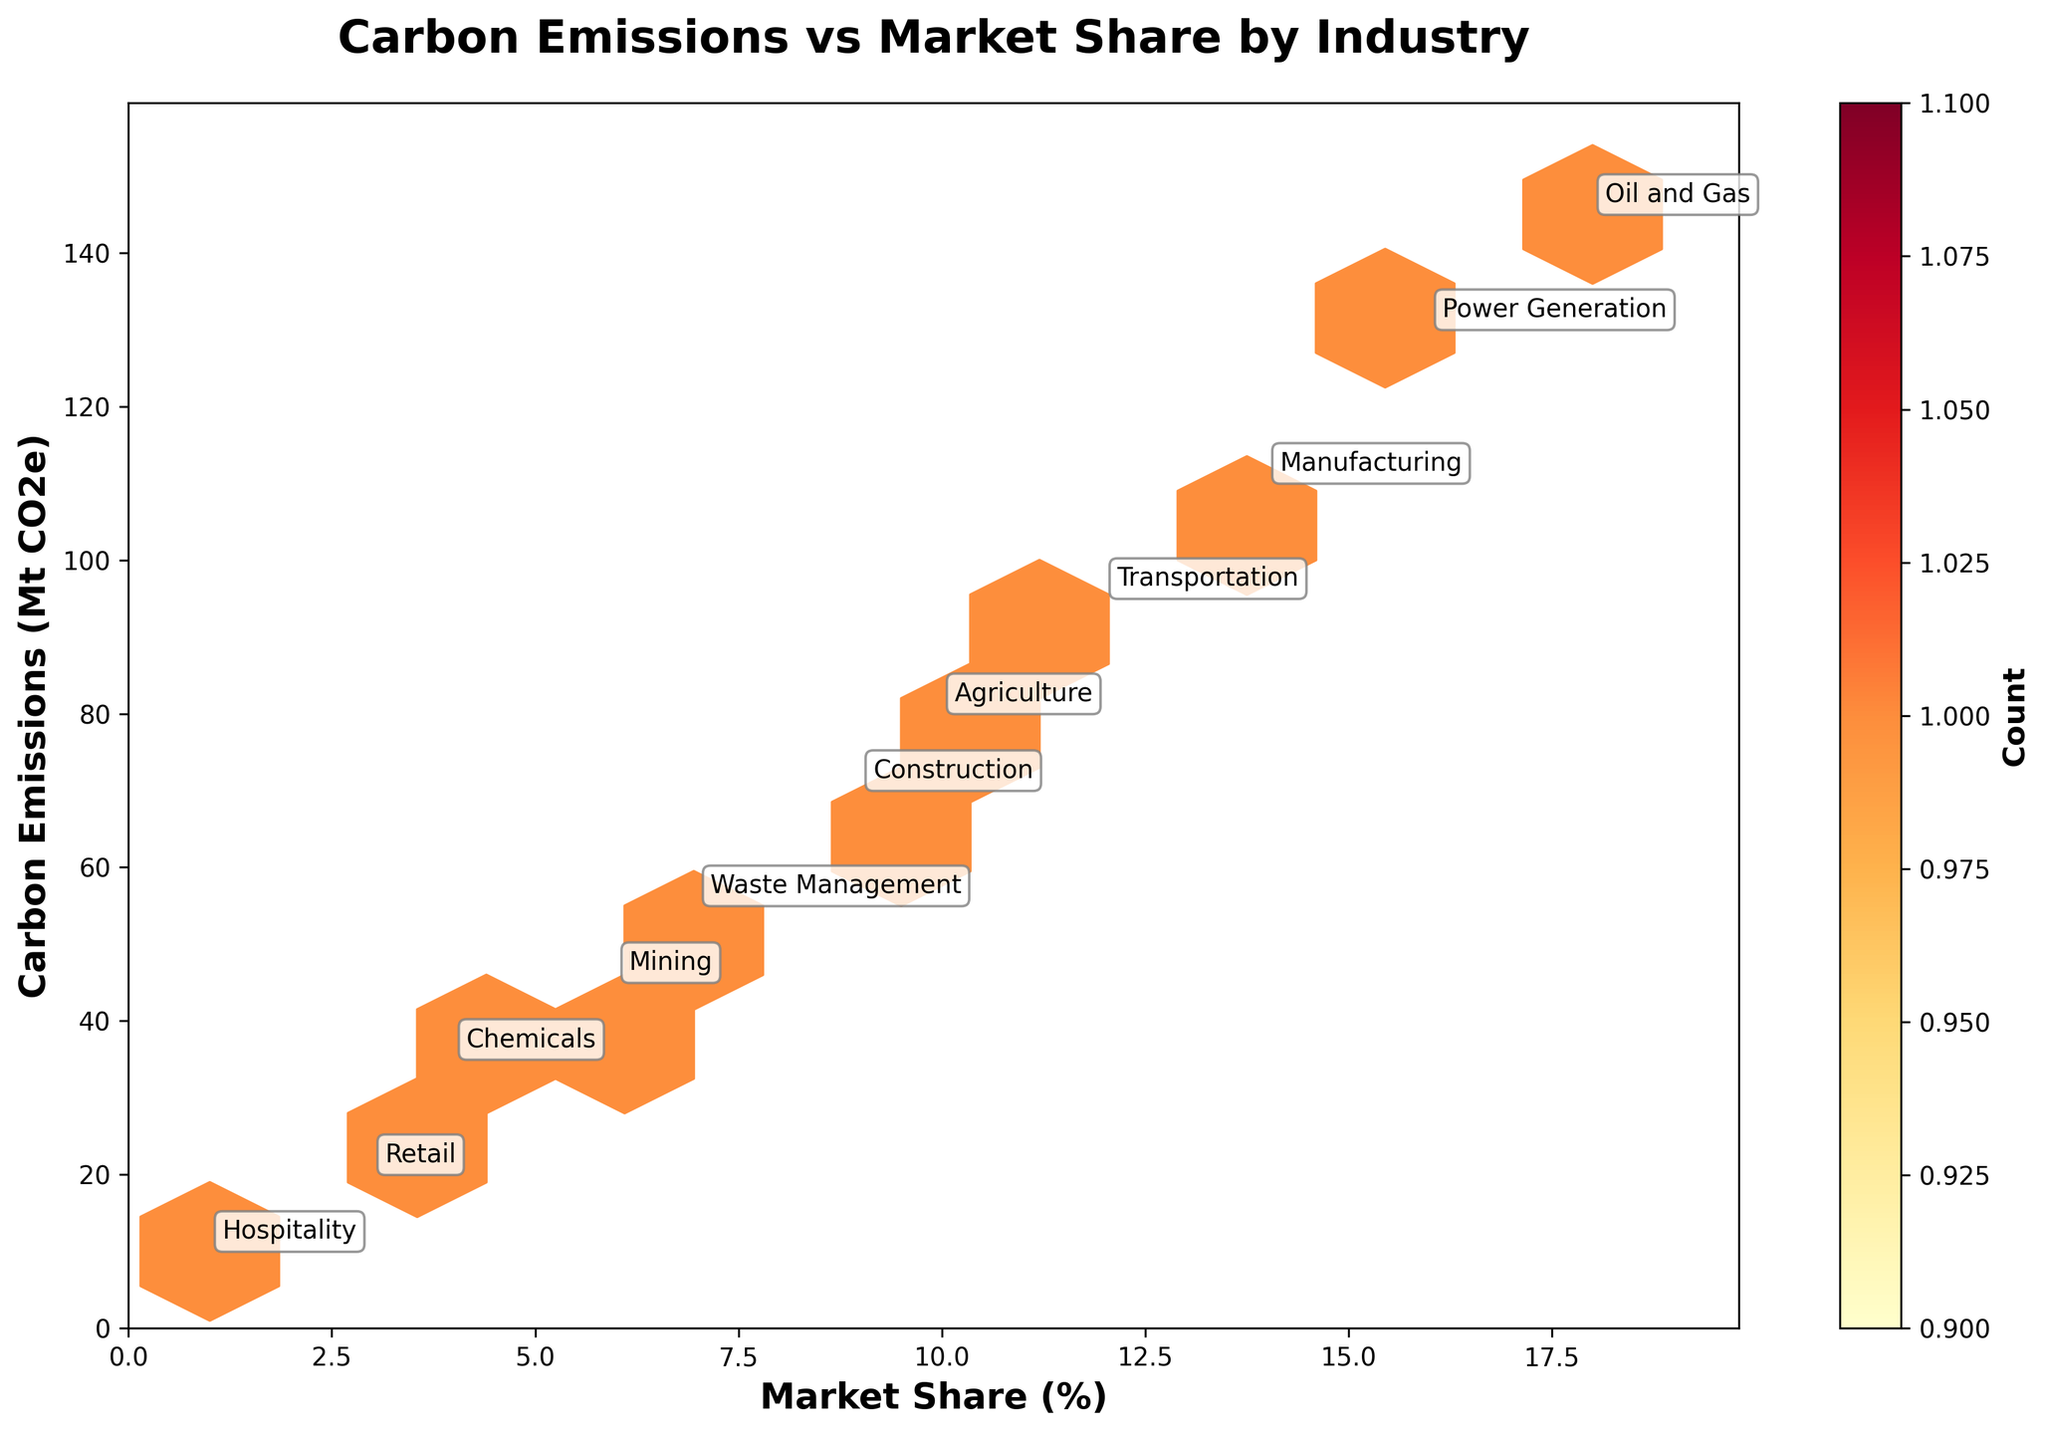What is the title of the plot? The title of the plot is displayed at the top of the figure and generally describes what the figure is about. In this case, it summarizes the content of the graph.
Answer: Carbon Emissions vs Market Share by Industry What color is used to represent the density of data points? The color used to represent the density of data points in a hexbin plot is typically indicated by the colorbar on the side of the plot. Here, different shades of yellow, orange, and red are used, with darker colors representing higher density areas.
Answer: Yellow to Red What is the market share percentage of the industry with the highest carbon emissions? To find this, locate the industry with the highest carbon emissions on the y-axis and then trace it to the corresponding market share on the x-axis. The Oil and Gas industry at 145 Mt CO2e has the highest carbon emissions.
Answer: 18% Which industry has the smallest carbon emissions and what is its market share percentage? To find this, locate the industry with the smallest carbon emissions on the y-axis and then look at the corresponding market share on the x-axis. The Hospitality industry with 10 Mt CO2e has the smallest emissions.
Answer: 1% How are the emissions and market share related among the industries shown in the plot? By examining the distribution of points, one can see whether there's a trend or pattern. Generally, the industries with higher emissions tend to have larger market shares, though there are variations.
Answer: Higher emissions often correlate with larger market shares What is the combined carbon emissions of Manufacturing and Transportation industries? The carbon emissions for Manufacturing and Transportation are 110 Mt CO2e and 95 Mt CO2e respectively. Summing them up: 110 + 95 = 205 Mt CO2e.
Answer: 205 Mt CO2e How does the carbon emission of Agriculture compare to that of Mining? Examine the carbon emissions of both industries on the y-axis. Agriculture has 80 Mt CO2e while Mining has 45 Mt CO2e. Comparing them shows that Agriculture has higher emissions.
Answer: Agriculture has higher emissions What is the sum of market share percentages for industries with carbon emissions less than 100 Mt CO2e? List the market share percentages for industries with emissions less than 100 Mt CO2e: Transportation (12%), Agriculture (10%), Construction (9%), Waste Management (7%), Mining (6%), Chemicals (4%), Retail (3%), Hospitality (1%). Sum these values: 12 + 10 + 9 + 7 + 6 + 4 + 3 + 1 = 52%.
Answer: 52% Which industries are annotated on the plot? The plot is annotated with industry names positioned near their corresponding data points. This makes it easier to identify which point represents which industry. All industries listed in the data table are annotated.
Answer: Oil and Gas, Power Generation, Manufacturing, Transportation, Agriculture, Construction, Waste Management, Mining, Chemicals, Retail, Hospitality 